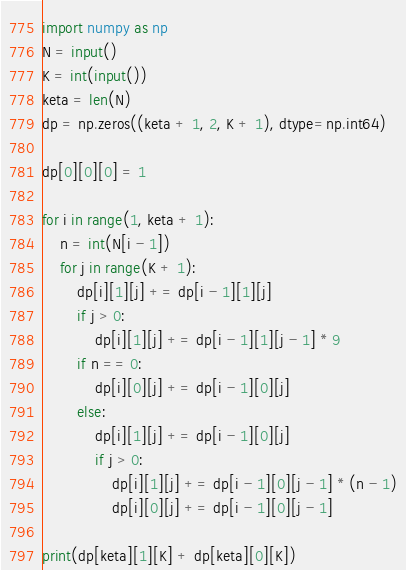<code> <loc_0><loc_0><loc_500><loc_500><_Python_>import numpy as np
N = input()
K = int(input())
keta = len(N)
dp = np.zeros((keta + 1, 2, K + 1), dtype=np.int64)

dp[0][0][0] = 1

for i in range(1, keta + 1):
    n = int(N[i - 1])
    for j in range(K + 1):
        dp[i][1][j] += dp[i - 1][1][j]
        if j > 0:
            dp[i][1][j] += dp[i - 1][1][j - 1] * 9
        if n == 0:
            dp[i][0][j] += dp[i - 1][0][j]
        else:
            dp[i][1][j] += dp[i - 1][0][j]
            if j > 0:
                dp[i][1][j] += dp[i - 1][0][j - 1] * (n - 1)
                dp[i][0][j] += dp[i - 1][0][j - 1]

print(dp[keta][1][K] + dp[keta][0][K])</code> 